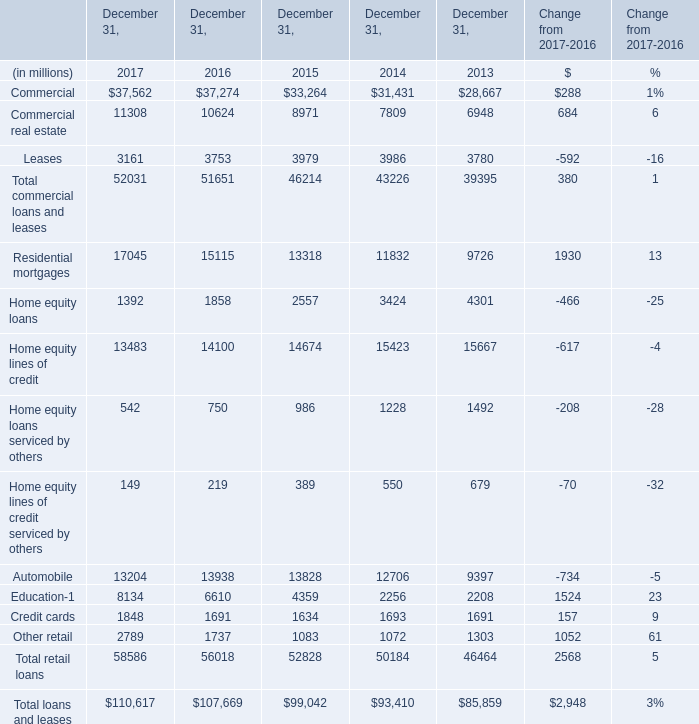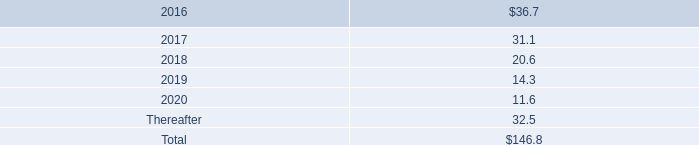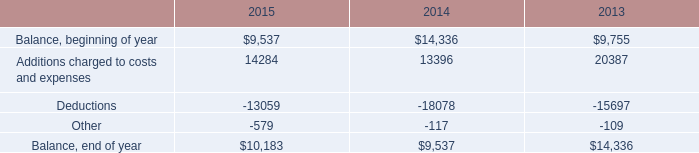What is the growing rate of Automobile in Table 0 in the year with the most Balance, beginning of year in Table 2? 
Computations: ((12706 - 9397) / 9397)
Answer: 0.35213. 